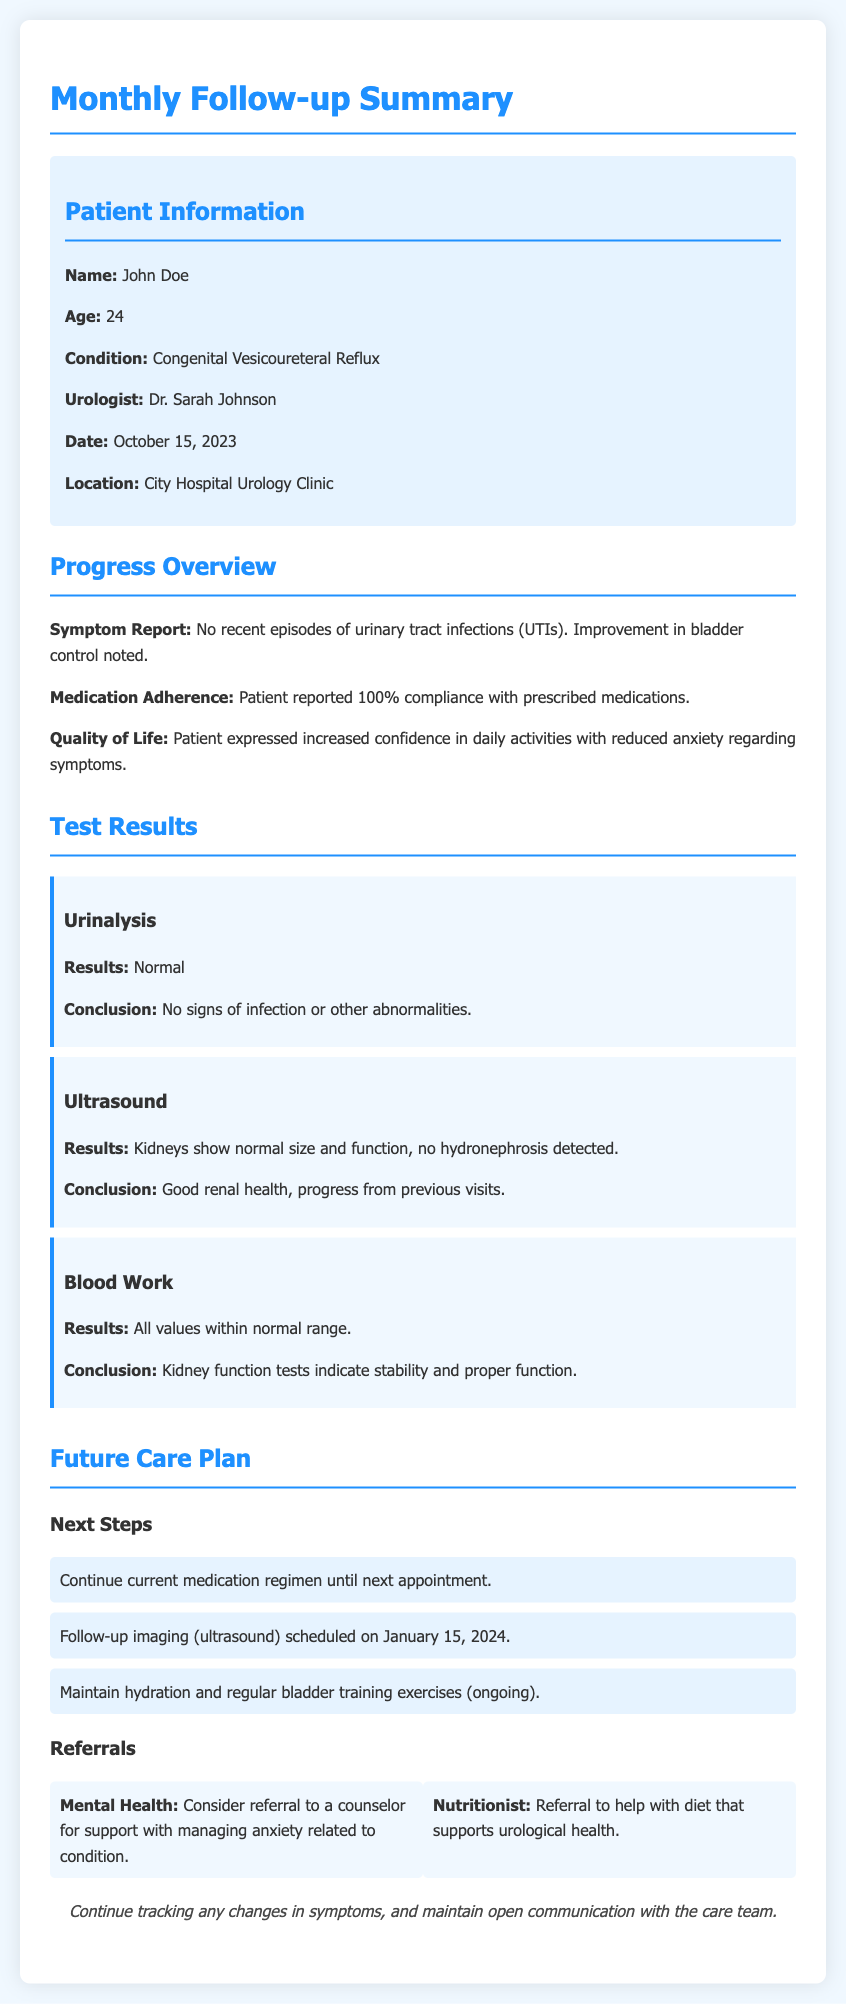What is the name of the patient? The patient's name is specified in the patient information section of the document.
Answer: John Doe What is the patient's age? The age of the patient is mentioned directly in the patient information section.
Answer: 24 What is the condition diagnosed? The document outlines the condition affecting the patient in the patient information section.
Answer: Congenital Vesicoureteral Reflux Who is the urologist? The urologist's name is included in the patient information section of the document.
Answer: Dr. Sarah Johnson What was the conclusion of the urinalysis? The conclusion regarding the urinalysis results is provided in the test results section.
Answer: No signs of infection or other abnormalities What is mentioned about medication adherence? The document provides a specific detail on medication adherence in the progress overview.
Answer: 100% compliance with prescribed medications What is the scheduled date for the follow-up imaging? The date for the follow-up imaging is noted in the future care plan section of the document.
Answer: January 15, 2024 What advice is given for tracking symptoms? The advice regarding tracking symptoms is mentioned at the end of the document.
Answer: Continue tracking any changes in symptoms What referral is suggested for nutrition? The document lists specific referrals under the future care plan section, including a nutritionist.
Answer: Referral to help with diet that supports urological health 